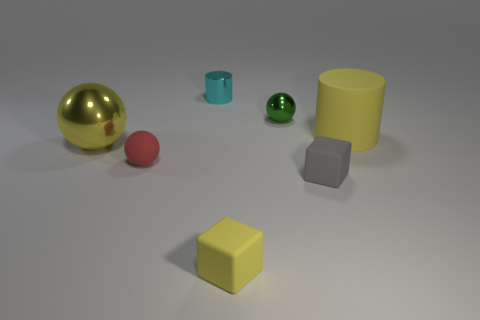Add 1 small matte blocks. How many objects exist? 8 Subtract all blocks. How many objects are left? 5 Subtract all small gray objects. Subtract all red balls. How many objects are left? 5 Add 1 yellow cylinders. How many yellow cylinders are left? 2 Add 3 blocks. How many blocks exist? 5 Subtract 0 brown balls. How many objects are left? 7 